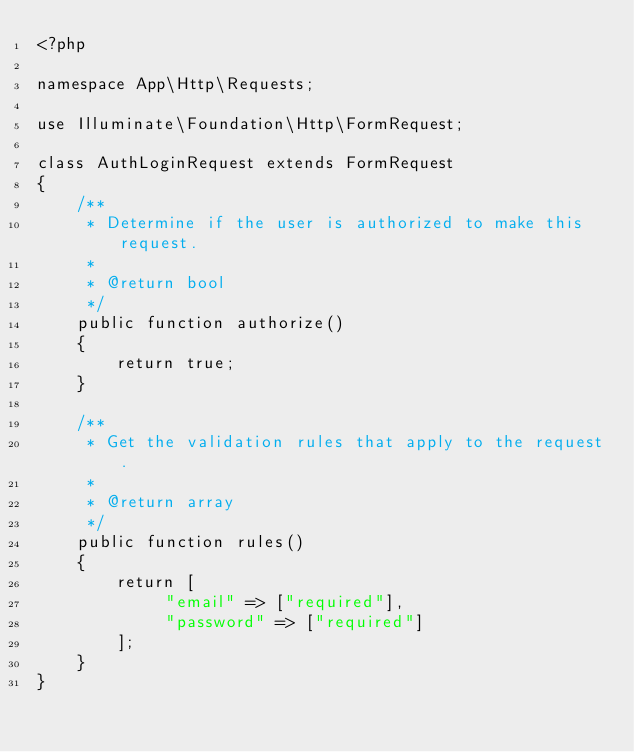Convert code to text. <code><loc_0><loc_0><loc_500><loc_500><_PHP_><?php

namespace App\Http\Requests;

use Illuminate\Foundation\Http\FormRequest;

class AuthLoginRequest extends FormRequest
{
    /**
     * Determine if the user is authorized to make this request.
     *
     * @return bool
     */
    public function authorize()
    {
        return true;
    }

    /**
     * Get the validation rules that apply to the request.
     *
     * @return array
     */
    public function rules()
    {
        return [
             "email" => ["required"],
             "password" => ["required"]
        ];
    }
}
</code> 